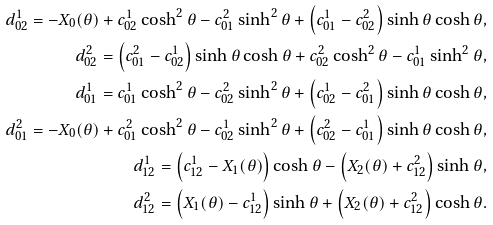Convert formula to latex. <formula><loc_0><loc_0><loc_500><loc_500>d _ { 0 2 } ^ { 1 } = - X _ { 0 } ( \theta ) + c _ { 0 2 } ^ { 1 } \cosh ^ { 2 } \theta - c _ { 0 1 } ^ { 2 } \sinh ^ { 2 } \theta + \left ( c _ { 0 1 } ^ { 1 } - c _ { 0 2 } ^ { 2 } \right ) \sinh \theta \cosh \theta , \\ d _ { 0 2 } ^ { 2 } = \left ( c _ { 0 1 } ^ { 2 } - c _ { 0 2 } ^ { 1 } \right ) \sinh \theta \cosh \theta + c _ { 0 2 } ^ { 2 } \cosh ^ { 2 } \theta - c _ { 0 1 } ^ { 1 } \sinh ^ { 2 } \theta , \\ d _ { 0 1 } ^ { 1 } = c _ { 0 1 } ^ { 1 } \cosh ^ { 2 } \theta - c _ { 0 2 } ^ { 2 } \sinh ^ { 2 } \theta + \left ( c _ { 0 2 } ^ { 1 } - c _ { 0 1 } ^ { 2 } \right ) \sinh \theta \cosh \theta , \\ d _ { 0 1 } ^ { 2 } = - X _ { 0 } ( \theta ) + c _ { 0 1 } ^ { 2 } \cosh ^ { 2 } \theta - c _ { 0 2 } ^ { 1 } \sinh ^ { 2 } \theta + \left ( c _ { 0 2 } ^ { 2 } - c _ { 0 1 } ^ { 1 } \right ) \sinh \theta \cosh \theta , \\ d _ { 1 2 } ^ { 1 } = \left ( c _ { 1 2 } ^ { 1 } - X _ { 1 } ( \theta ) \right ) \cosh \theta - \left ( X _ { 2 } ( \theta ) + c _ { 1 2 } ^ { 2 } \right ) \sinh \theta , \\ d _ { 1 2 } ^ { 2 } = \left ( X _ { 1 } ( \theta ) - c _ { 1 2 } ^ { 1 } \right ) \sinh \theta + \left ( X _ { 2 } ( \theta ) + c _ { 1 2 } ^ { 2 } \right ) \cosh \theta .</formula> 